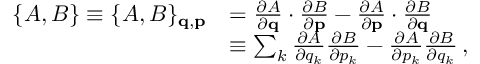Convert formula to latex. <formula><loc_0><loc_0><loc_500><loc_500>{ \begin{array} { r l } { \{ A , B \} \equiv \{ A , B \} _ { q , p } } & { = { \frac { \partial A } { \partial q } } \cdot { \frac { \partial B } { \partial p } } - { \frac { \partial A } { \partial p } } \cdot { \frac { \partial B } { \partial q } } } \\ & { \equiv \sum _ { k } { \frac { \partial A } { \partial q _ { k } } } { \frac { \partial B } { \partial p _ { k } } } - { \frac { \partial A } { \partial p _ { k } } } { \frac { \partial B } { \partial q _ { k } } } \, , } \end{array} }</formula> 